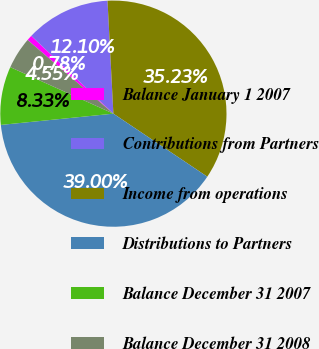Convert chart to OTSL. <chart><loc_0><loc_0><loc_500><loc_500><pie_chart><fcel>Balance January 1 2007<fcel>Contributions from Partners<fcel>Income from operations<fcel>Distributions to Partners<fcel>Balance December 31 2007<fcel>Balance December 31 2008<nl><fcel>0.78%<fcel>12.1%<fcel>35.23%<fcel>39.0%<fcel>8.33%<fcel>4.55%<nl></chart> 